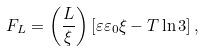<formula> <loc_0><loc_0><loc_500><loc_500>F _ { L } = \left ( \frac { L } { \xi } \right ) \left [ \varepsilon \varepsilon _ { 0 } \xi - T \ln 3 \right ] ,</formula> 